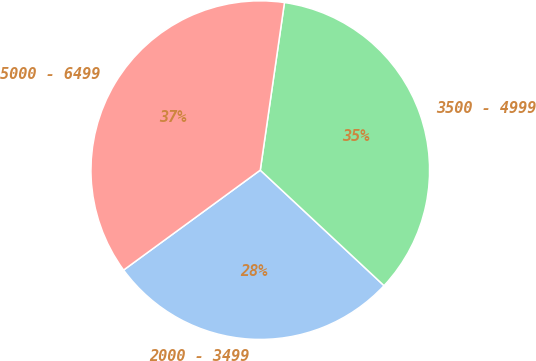<chart> <loc_0><loc_0><loc_500><loc_500><pie_chart><fcel>2000 - 3499<fcel>3500 - 4999<fcel>5000 - 6499<nl><fcel>28.0%<fcel>34.67%<fcel>37.33%<nl></chart> 